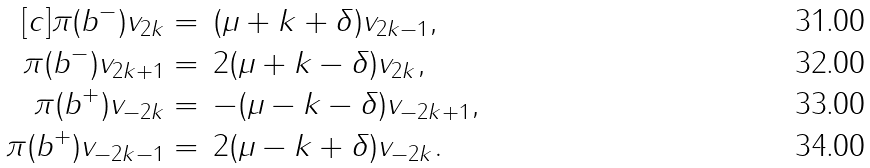<formula> <loc_0><loc_0><loc_500><loc_500>[ c ] \pi ( b ^ { - } ) v _ { 2 k } & = \, ( \mu + k + \delta ) v _ { 2 k - 1 } , \\ \pi ( b ^ { - } ) v _ { 2 k + 1 } & = \, 2 ( \mu + k - \delta ) v _ { 2 k } , \\ \pi ( b ^ { + } ) v _ { - 2 k } & = \, - ( \mu - k - \delta ) v _ { - 2 k + 1 } , \\ \pi ( b ^ { + } ) v _ { - 2 k - 1 } & = \, 2 ( \mu - k + \delta ) v _ { - 2 k } .</formula> 